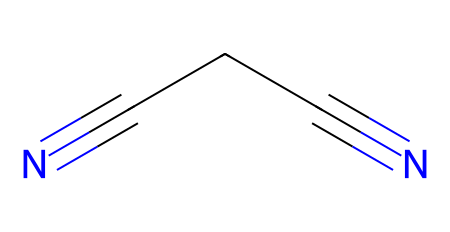What is the name of this chemical? The SMILES representation shows a compound with the structure N#CCCN (nitrile groups), which is known as succinonitrile.
Answer: succinonitrile How many carbon atoms are present? The chemical structure contains three carbon atoms connected by single and triple bonds, visible in the SMILES representation.
Answer: 3 What type of compound is succinonitrile? The presence of the nitrile functional groups (-C≡N) indicates that this is a nitrile compound.
Answer: nitrile What is the total number of nitrogen atoms? The SMILES representation shows two nitrogen atoms connected to the carbon chain (end functional groups), giving a total of two nitrogen atoms.
Answer: 2 Which bond type is predominant in the nitrile functional group? The nitrile functional group is characterized by a triple bond between carbon and nitrogen, which is shown in the chemical structure as "-C≡N".
Answer: triple bond What molecular feature allows succinonitrile to act as a battery electrolyte? Succinonitrile's low viscosity and the presence of nitrile groups facilitate ionic conductivity, making it suitable for use in battery electrolytes.
Answer: ionic conductivity 